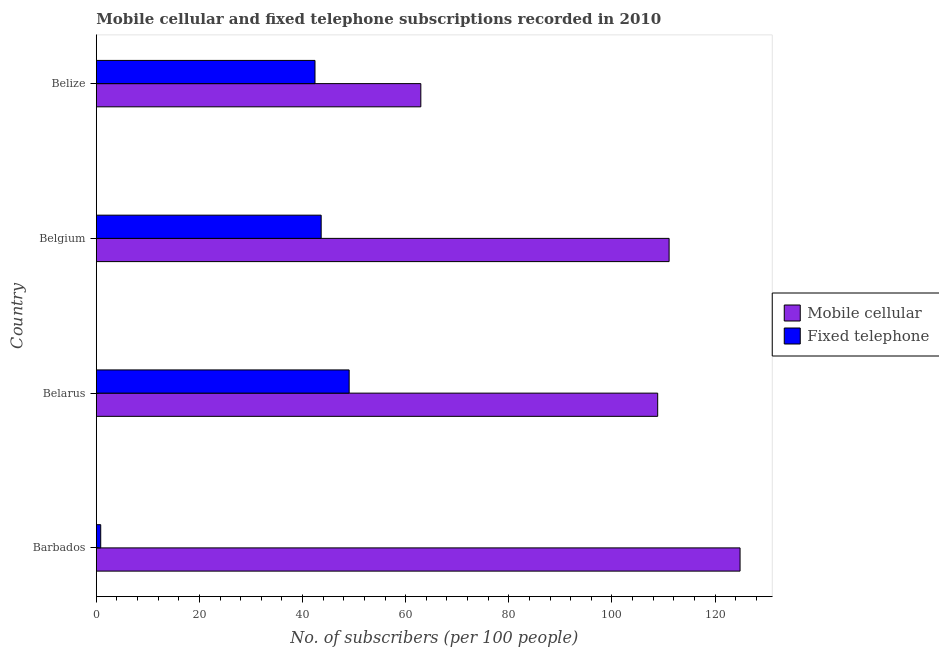How many different coloured bars are there?
Give a very brief answer. 2. How many groups of bars are there?
Make the answer very short. 4. Are the number of bars on each tick of the Y-axis equal?
Your response must be concise. Yes. How many bars are there on the 2nd tick from the bottom?
Make the answer very short. 2. What is the label of the 4th group of bars from the top?
Your answer should be compact. Barbados. In how many cases, is the number of bars for a given country not equal to the number of legend labels?
Offer a very short reply. 0. What is the number of mobile cellular subscribers in Belarus?
Provide a succinct answer. 108.87. Across all countries, what is the maximum number of mobile cellular subscribers?
Keep it short and to the point. 124.85. Across all countries, what is the minimum number of mobile cellular subscribers?
Give a very brief answer. 62.93. In which country was the number of mobile cellular subscribers maximum?
Make the answer very short. Barbados. In which country was the number of fixed telephone subscribers minimum?
Make the answer very short. Barbados. What is the total number of mobile cellular subscribers in the graph?
Make the answer very short. 407.73. What is the difference between the number of fixed telephone subscribers in Barbados and that in Belgium?
Make the answer very short. -42.76. What is the difference between the number of mobile cellular subscribers in Belgium and the number of fixed telephone subscribers in Barbados?
Offer a terse response. 110.24. What is the average number of fixed telephone subscribers per country?
Provide a succinct answer. 33.97. What is the difference between the number of fixed telephone subscribers and number of mobile cellular subscribers in Barbados?
Provide a short and direct response. -124. In how many countries, is the number of mobile cellular subscribers greater than 56 ?
Ensure brevity in your answer.  4. What is the ratio of the number of fixed telephone subscribers in Belarus to that in Belize?
Provide a succinct answer. 1.16. Is the number of mobile cellular subscribers in Belarus less than that in Belize?
Keep it short and to the point. No. Is the difference between the number of mobile cellular subscribers in Barbados and Belarus greater than the difference between the number of fixed telephone subscribers in Barbados and Belarus?
Make the answer very short. Yes. What is the difference between the highest and the second highest number of fixed telephone subscribers?
Your answer should be compact. 5.43. What is the difference between the highest and the lowest number of fixed telephone subscribers?
Give a very brief answer. 48.19. Is the sum of the number of fixed telephone subscribers in Belarus and Belgium greater than the maximum number of mobile cellular subscribers across all countries?
Your response must be concise. No. What does the 1st bar from the top in Belize represents?
Offer a very short reply. Fixed telephone. What does the 1st bar from the bottom in Belgium represents?
Your answer should be very brief. Mobile cellular. Are all the bars in the graph horizontal?
Your answer should be very brief. Yes. How many countries are there in the graph?
Offer a very short reply. 4. What is the difference between two consecutive major ticks on the X-axis?
Your response must be concise. 20. Does the graph contain any zero values?
Your answer should be compact. No. What is the title of the graph?
Make the answer very short. Mobile cellular and fixed telephone subscriptions recorded in 2010. What is the label or title of the X-axis?
Provide a short and direct response. No. of subscribers (per 100 people). What is the label or title of the Y-axis?
Your answer should be compact. Country. What is the No. of subscribers (per 100 people) in Mobile cellular in Barbados?
Your answer should be very brief. 124.85. What is the No. of subscribers (per 100 people) of Fixed telephone in Barbados?
Offer a terse response. 0.85. What is the No. of subscribers (per 100 people) of Mobile cellular in Belarus?
Make the answer very short. 108.87. What is the No. of subscribers (per 100 people) in Fixed telephone in Belarus?
Provide a short and direct response. 49.03. What is the No. of subscribers (per 100 people) of Mobile cellular in Belgium?
Ensure brevity in your answer.  111.08. What is the No. of subscribers (per 100 people) of Fixed telephone in Belgium?
Keep it short and to the point. 43.61. What is the No. of subscribers (per 100 people) in Mobile cellular in Belize?
Offer a terse response. 62.93. What is the No. of subscribers (per 100 people) in Fixed telephone in Belize?
Your response must be concise. 42.41. Across all countries, what is the maximum No. of subscribers (per 100 people) of Mobile cellular?
Make the answer very short. 124.85. Across all countries, what is the maximum No. of subscribers (per 100 people) in Fixed telephone?
Your answer should be very brief. 49.03. Across all countries, what is the minimum No. of subscribers (per 100 people) in Mobile cellular?
Provide a succinct answer. 62.93. Across all countries, what is the minimum No. of subscribers (per 100 people) in Fixed telephone?
Keep it short and to the point. 0.85. What is the total No. of subscribers (per 100 people) of Mobile cellular in the graph?
Your response must be concise. 407.73. What is the total No. of subscribers (per 100 people) of Fixed telephone in the graph?
Ensure brevity in your answer.  135.89. What is the difference between the No. of subscribers (per 100 people) of Mobile cellular in Barbados and that in Belarus?
Provide a short and direct response. 15.98. What is the difference between the No. of subscribers (per 100 people) of Fixed telephone in Barbados and that in Belarus?
Ensure brevity in your answer.  -48.19. What is the difference between the No. of subscribers (per 100 people) in Mobile cellular in Barbados and that in Belgium?
Keep it short and to the point. 13.76. What is the difference between the No. of subscribers (per 100 people) of Fixed telephone in Barbados and that in Belgium?
Give a very brief answer. -42.76. What is the difference between the No. of subscribers (per 100 people) of Mobile cellular in Barbados and that in Belize?
Offer a terse response. 61.91. What is the difference between the No. of subscribers (per 100 people) of Fixed telephone in Barbados and that in Belize?
Your answer should be very brief. -41.56. What is the difference between the No. of subscribers (per 100 people) of Mobile cellular in Belarus and that in Belgium?
Provide a short and direct response. -2.21. What is the difference between the No. of subscribers (per 100 people) in Fixed telephone in Belarus and that in Belgium?
Your response must be concise. 5.43. What is the difference between the No. of subscribers (per 100 people) of Mobile cellular in Belarus and that in Belize?
Provide a succinct answer. 45.94. What is the difference between the No. of subscribers (per 100 people) of Fixed telephone in Belarus and that in Belize?
Give a very brief answer. 6.63. What is the difference between the No. of subscribers (per 100 people) of Mobile cellular in Belgium and that in Belize?
Provide a succinct answer. 48.15. What is the difference between the No. of subscribers (per 100 people) in Fixed telephone in Belgium and that in Belize?
Your answer should be very brief. 1.2. What is the difference between the No. of subscribers (per 100 people) of Mobile cellular in Barbados and the No. of subscribers (per 100 people) of Fixed telephone in Belarus?
Provide a short and direct response. 75.81. What is the difference between the No. of subscribers (per 100 people) in Mobile cellular in Barbados and the No. of subscribers (per 100 people) in Fixed telephone in Belgium?
Provide a short and direct response. 81.24. What is the difference between the No. of subscribers (per 100 people) in Mobile cellular in Barbados and the No. of subscribers (per 100 people) in Fixed telephone in Belize?
Your answer should be very brief. 82.44. What is the difference between the No. of subscribers (per 100 people) of Mobile cellular in Belarus and the No. of subscribers (per 100 people) of Fixed telephone in Belgium?
Provide a succinct answer. 65.26. What is the difference between the No. of subscribers (per 100 people) of Mobile cellular in Belarus and the No. of subscribers (per 100 people) of Fixed telephone in Belize?
Your response must be concise. 66.46. What is the difference between the No. of subscribers (per 100 people) in Mobile cellular in Belgium and the No. of subscribers (per 100 people) in Fixed telephone in Belize?
Provide a succinct answer. 68.68. What is the average No. of subscribers (per 100 people) of Mobile cellular per country?
Your answer should be compact. 101.93. What is the average No. of subscribers (per 100 people) in Fixed telephone per country?
Your answer should be compact. 33.97. What is the difference between the No. of subscribers (per 100 people) of Mobile cellular and No. of subscribers (per 100 people) of Fixed telephone in Barbados?
Offer a very short reply. 124. What is the difference between the No. of subscribers (per 100 people) in Mobile cellular and No. of subscribers (per 100 people) in Fixed telephone in Belarus?
Keep it short and to the point. 59.84. What is the difference between the No. of subscribers (per 100 people) in Mobile cellular and No. of subscribers (per 100 people) in Fixed telephone in Belgium?
Give a very brief answer. 67.48. What is the difference between the No. of subscribers (per 100 people) of Mobile cellular and No. of subscribers (per 100 people) of Fixed telephone in Belize?
Offer a very short reply. 20.52. What is the ratio of the No. of subscribers (per 100 people) of Mobile cellular in Barbados to that in Belarus?
Provide a succinct answer. 1.15. What is the ratio of the No. of subscribers (per 100 people) of Fixed telephone in Barbados to that in Belarus?
Give a very brief answer. 0.02. What is the ratio of the No. of subscribers (per 100 people) in Mobile cellular in Barbados to that in Belgium?
Keep it short and to the point. 1.12. What is the ratio of the No. of subscribers (per 100 people) in Fixed telephone in Barbados to that in Belgium?
Provide a short and direct response. 0.02. What is the ratio of the No. of subscribers (per 100 people) in Mobile cellular in Barbados to that in Belize?
Give a very brief answer. 1.98. What is the ratio of the No. of subscribers (per 100 people) in Mobile cellular in Belarus to that in Belgium?
Your answer should be very brief. 0.98. What is the ratio of the No. of subscribers (per 100 people) in Fixed telephone in Belarus to that in Belgium?
Provide a succinct answer. 1.12. What is the ratio of the No. of subscribers (per 100 people) of Mobile cellular in Belarus to that in Belize?
Make the answer very short. 1.73. What is the ratio of the No. of subscribers (per 100 people) in Fixed telephone in Belarus to that in Belize?
Provide a succinct answer. 1.16. What is the ratio of the No. of subscribers (per 100 people) in Mobile cellular in Belgium to that in Belize?
Keep it short and to the point. 1.77. What is the ratio of the No. of subscribers (per 100 people) in Fixed telephone in Belgium to that in Belize?
Ensure brevity in your answer.  1.03. What is the difference between the highest and the second highest No. of subscribers (per 100 people) of Mobile cellular?
Ensure brevity in your answer.  13.76. What is the difference between the highest and the second highest No. of subscribers (per 100 people) in Fixed telephone?
Make the answer very short. 5.43. What is the difference between the highest and the lowest No. of subscribers (per 100 people) of Mobile cellular?
Ensure brevity in your answer.  61.91. What is the difference between the highest and the lowest No. of subscribers (per 100 people) in Fixed telephone?
Your response must be concise. 48.19. 